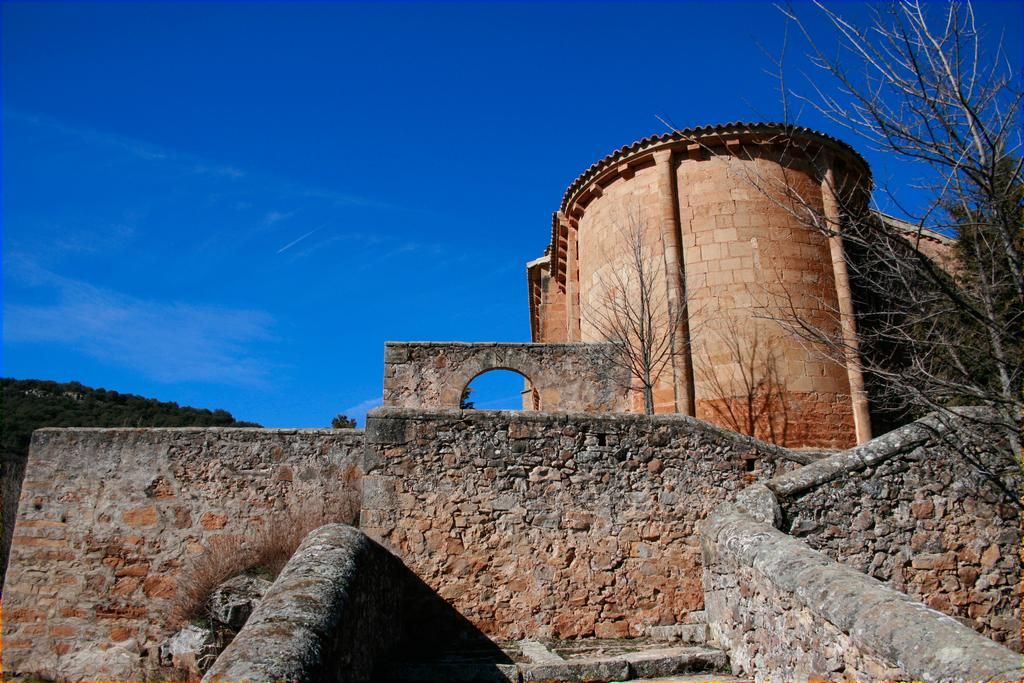What type of structure is present in the image? There is a fort in the image. What other natural elements can be seen in the image? There are trees in the image. What is visible in the background of the image? The sky is visible in the background of the image. What is the color of the sky in the image? The color of the sky is blue. Can you see a bear holding a needle in the image? No, there is no bear or needle present in the image. 